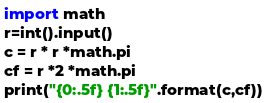Convert code to text. <code><loc_0><loc_0><loc_500><loc_500><_Python_>import math
r=int().input()
c = r * r *math.pi
cf = r *2 *math.pi
print("{0:.5f} {1:.5f}".format(c,cf))</code> 